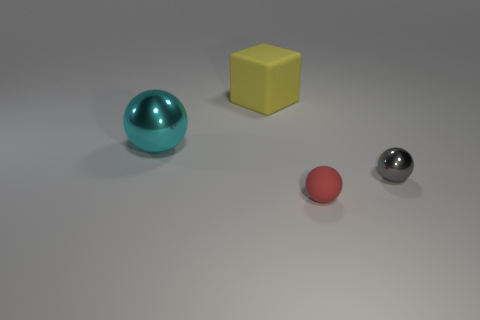Add 2 small cyan cylinders. How many objects exist? 6 Subtract all cubes. How many objects are left? 3 Add 4 tiny cyan matte cubes. How many tiny cyan matte cubes exist? 4 Subtract 1 cyan balls. How many objects are left? 3 Subtract all small cyan matte things. Subtract all red rubber spheres. How many objects are left? 3 Add 1 large cyan objects. How many large cyan objects are left? 2 